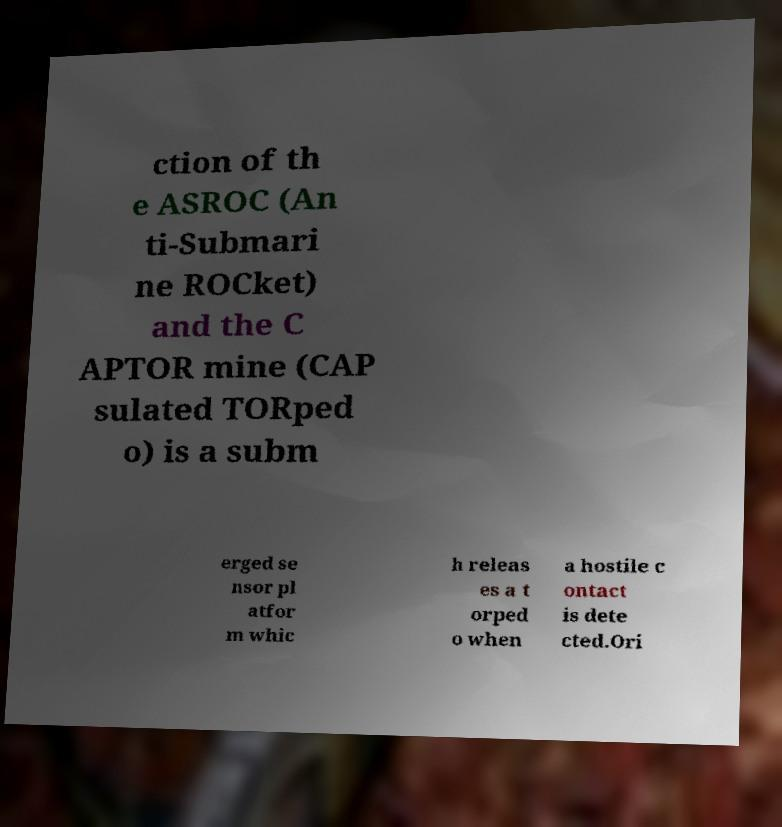I need the written content from this picture converted into text. Can you do that? ction of th e ASROC (An ti-Submari ne ROCket) and the C APTOR mine (CAP sulated TORped o) is a subm erged se nsor pl atfor m whic h releas es a t orped o when a hostile c ontact is dete cted.Ori 